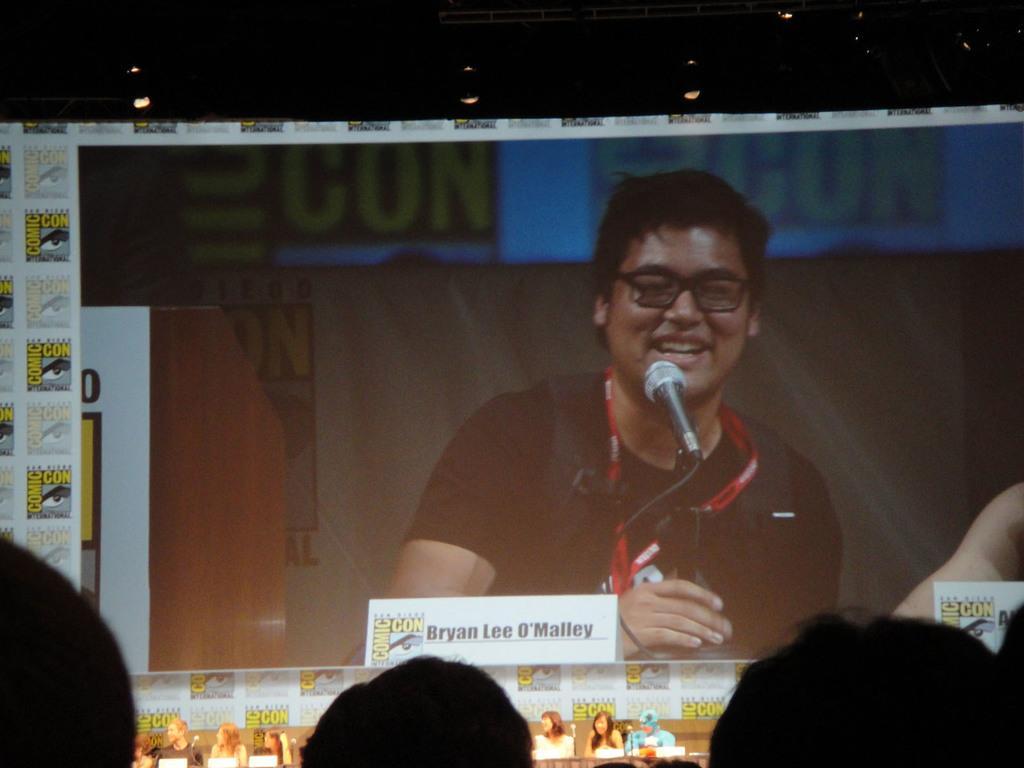How would you summarize this image in a sentence or two? In the picture I can see the screen. On the screen I can see a man smiling and he is holding a microphone. I can see a few persons at the bottom of the picture. There is a lighting arrangement at the top of the picture. 